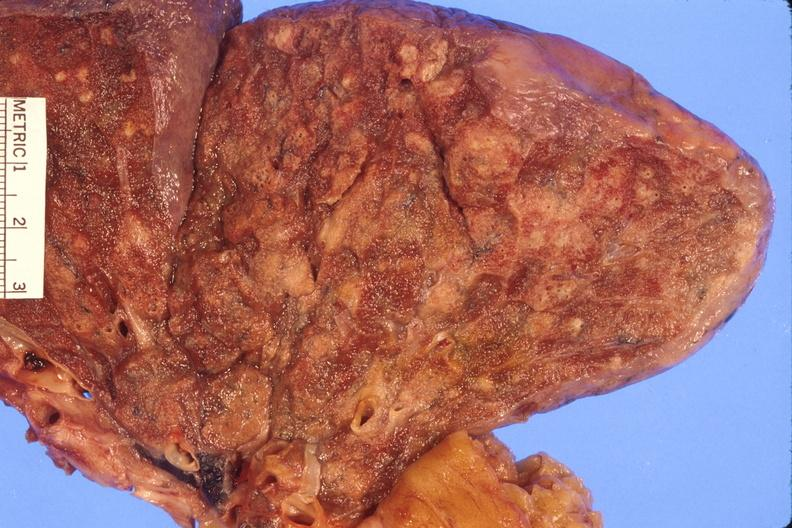where is this?
Answer the question using a single word or phrase. Lung 